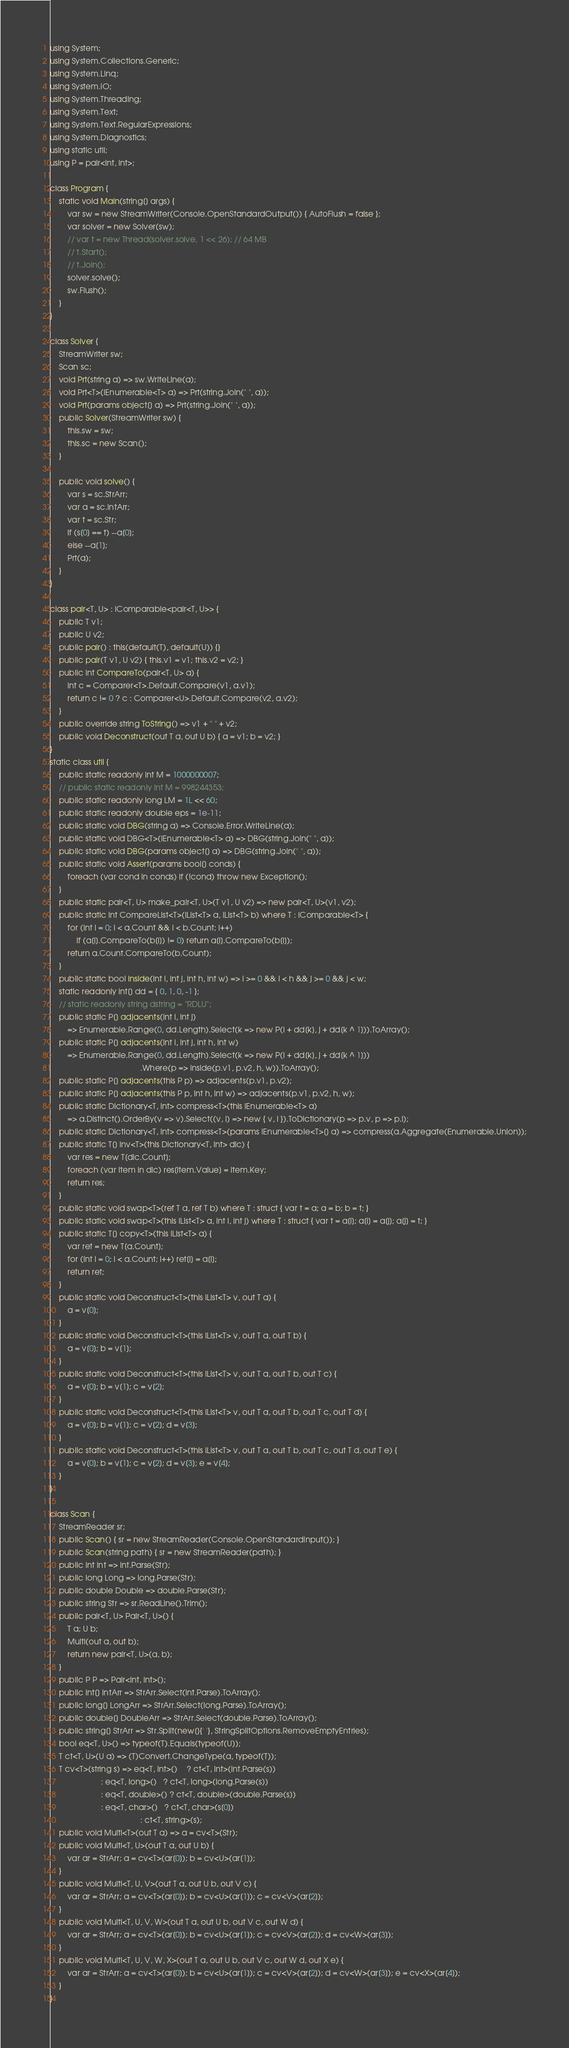Convert code to text. <code><loc_0><loc_0><loc_500><loc_500><_C#_>using System;
using System.Collections.Generic;
using System.Linq;
using System.IO;
using System.Threading;
using System.Text;
using System.Text.RegularExpressions;
using System.Diagnostics;
using static util;
using P = pair<int, int>;

class Program {
    static void Main(string[] args) {
        var sw = new StreamWriter(Console.OpenStandardOutput()) { AutoFlush = false };
        var solver = new Solver(sw);
        // var t = new Thread(solver.solve, 1 << 26); // 64 MB
        // t.Start();
        // t.Join();
        solver.solve();
        sw.Flush();
    }
}

class Solver {
    StreamWriter sw;
    Scan sc;
    void Prt(string a) => sw.WriteLine(a);
    void Prt<T>(IEnumerable<T> a) => Prt(string.Join(" ", a));
    void Prt(params object[] a) => Prt(string.Join(" ", a));
    public Solver(StreamWriter sw) {
        this.sw = sw;
        this.sc = new Scan();
    }

    public void solve() {
        var s = sc.StrArr;
        var a = sc.IntArr;
        var t = sc.Str;
        if (s[0] == t) --a[0];
        else --a[1];
        Prt(a);
    }
}

class pair<T, U> : IComparable<pair<T, U>> {
    public T v1;
    public U v2;
    public pair() : this(default(T), default(U)) {}
    public pair(T v1, U v2) { this.v1 = v1; this.v2 = v2; }
    public int CompareTo(pair<T, U> a) {
        int c = Comparer<T>.Default.Compare(v1, a.v1);
        return c != 0 ? c : Comparer<U>.Default.Compare(v2, a.v2);
    }
    public override string ToString() => v1 + " " + v2;
    public void Deconstruct(out T a, out U b) { a = v1; b = v2; }
}
static class util {
    public static readonly int M = 1000000007;
    // public static readonly int M = 998244353;
    public static readonly long LM = 1L << 60;
    public static readonly double eps = 1e-11;
    public static void DBG(string a) => Console.Error.WriteLine(a);
    public static void DBG<T>(IEnumerable<T> a) => DBG(string.Join(" ", a));
    public static void DBG(params object[] a) => DBG(string.Join(" ", a));
    public static void Assert(params bool[] conds) {
        foreach (var cond in conds) if (!cond) throw new Exception();
    }
    public static pair<T, U> make_pair<T, U>(T v1, U v2) => new pair<T, U>(v1, v2);
    public static int CompareList<T>(IList<T> a, IList<T> b) where T : IComparable<T> {
        for (int i = 0; i < a.Count && i < b.Count; i++)
            if (a[i].CompareTo(b[i]) != 0) return a[i].CompareTo(b[i]);
        return a.Count.CompareTo(b.Count);
    }
    public static bool inside(int i, int j, int h, int w) => i >= 0 && i < h && j >= 0 && j < w;
    static readonly int[] dd = { 0, 1, 0, -1 };
    // static readonly string dstring = "RDLU";
    public static P[] adjacents(int i, int j)
        => Enumerable.Range(0, dd.Length).Select(k => new P(i + dd[k], j + dd[k ^ 1])).ToArray();
    public static P[] adjacents(int i, int j, int h, int w)
        => Enumerable.Range(0, dd.Length).Select(k => new P(i + dd[k], j + dd[k ^ 1]))
                                         .Where(p => inside(p.v1, p.v2, h, w)).ToArray();
    public static P[] adjacents(this P p) => adjacents(p.v1, p.v2);
    public static P[] adjacents(this P p, int h, int w) => adjacents(p.v1, p.v2, h, w);
    public static Dictionary<T, int> compress<T>(this IEnumerable<T> a)
        => a.Distinct().OrderBy(v => v).Select((v, i) => new { v, i }).ToDictionary(p => p.v, p => p.i);
    public static Dictionary<T, int> compress<T>(params IEnumerable<T>[] a) => compress(a.Aggregate(Enumerable.Union));
    public static T[] inv<T>(this Dictionary<T, int> dic) {
        var res = new T[dic.Count];
        foreach (var item in dic) res[item.Value] = item.Key;
        return res;
    }
    public static void swap<T>(ref T a, ref T b) where T : struct { var t = a; a = b; b = t; }
    public static void swap<T>(this IList<T> a, int i, int j) where T : struct { var t = a[i]; a[i] = a[j]; a[j] = t; }
    public static T[] copy<T>(this IList<T> a) {
        var ret = new T[a.Count];
        for (int i = 0; i < a.Count; i++) ret[i] = a[i];
        return ret;
    }
    public static void Deconstruct<T>(this IList<T> v, out T a) {
        a = v[0];
    }
    public static void Deconstruct<T>(this IList<T> v, out T a, out T b) {
        a = v[0]; b = v[1];
    }
    public static void Deconstruct<T>(this IList<T> v, out T a, out T b, out T c) {
        a = v[0]; b = v[1]; c = v[2];
    }
    public static void Deconstruct<T>(this IList<T> v, out T a, out T b, out T c, out T d) {
        a = v[0]; b = v[1]; c = v[2]; d = v[3];
    }
    public static void Deconstruct<T>(this IList<T> v, out T a, out T b, out T c, out T d, out T e) {
        a = v[0]; b = v[1]; c = v[2]; d = v[3]; e = v[4];
    }
}

class Scan {
    StreamReader sr;
    public Scan() { sr = new StreamReader(Console.OpenStandardInput()); }
    public Scan(string path) { sr = new StreamReader(path); }
    public int Int => int.Parse(Str);
    public long Long => long.Parse(Str);
    public double Double => double.Parse(Str);
    public string Str => sr.ReadLine().Trim();
    public pair<T, U> Pair<T, U>() {
        T a; U b;
        Multi(out a, out b);
        return new pair<T, U>(a, b);
    }
    public P P => Pair<int, int>();
    public int[] IntArr => StrArr.Select(int.Parse).ToArray();
    public long[] LongArr => StrArr.Select(long.Parse).ToArray();
    public double[] DoubleArr => StrArr.Select(double.Parse).ToArray();
    public string[] StrArr => Str.Split(new[]{' '}, StringSplitOptions.RemoveEmptyEntries);
    bool eq<T, U>() => typeof(T).Equals(typeof(U));
    T ct<T, U>(U a) => (T)Convert.ChangeType(a, typeof(T));
    T cv<T>(string s) => eq<T, int>()    ? ct<T, int>(int.Parse(s))
                       : eq<T, long>()   ? ct<T, long>(long.Parse(s))
                       : eq<T, double>() ? ct<T, double>(double.Parse(s))
                       : eq<T, char>()   ? ct<T, char>(s[0])
                                         : ct<T, string>(s);
    public void Multi<T>(out T a) => a = cv<T>(Str);
    public void Multi<T, U>(out T a, out U b) {
        var ar = StrArr; a = cv<T>(ar[0]); b = cv<U>(ar[1]);
    }
    public void Multi<T, U, V>(out T a, out U b, out V c) {
        var ar = StrArr; a = cv<T>(ar[0]); b = cv<U>(ar[1]); c = cv<V>(ar[2]);
    }
    public void Multi<T, U, V, W>(out T a, out U b, out V c, out W d) {
        var ar = StrArr; a = cv<T>(ar[0]); b = cv<U>(ar[1]); c = cv<V>(ar[2]); d = cv<W>(ar[3]);
    }
    public void Multi<T, U, V, W, X>(out T a, out U b, out V c, out W d, out X e) {
        var ar = StrArr; a = cv<T>(ar[0]); b = cv<U>(ar[1]); c = cv<V>(ar[2]); d = cv<W>(ar[3]); e = cv<X>(ar[4]);
    }
}
</code> 